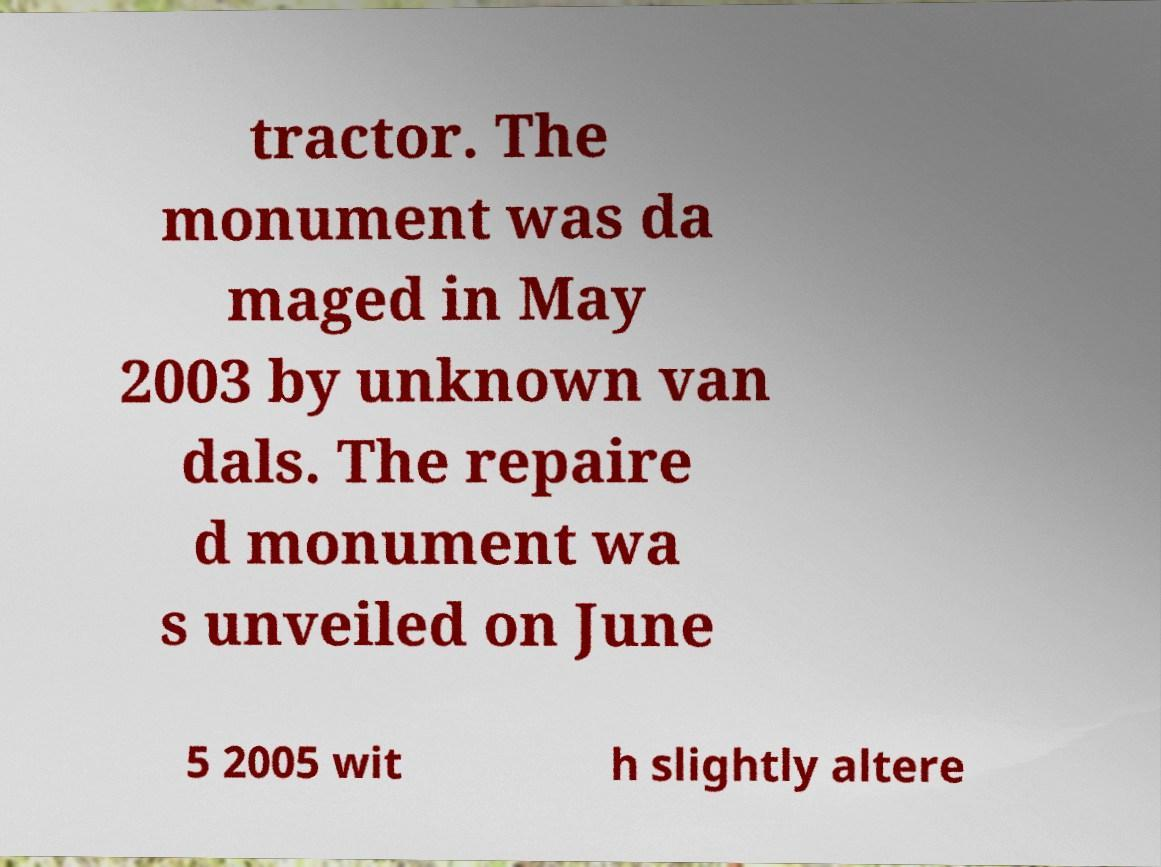Could you extract and type out the text from this image? tractor. The monument was da maged in May 2003 by unknown van dals. The repaire d monument wa s unveiled on June 5 2005 wit h slightly altere 